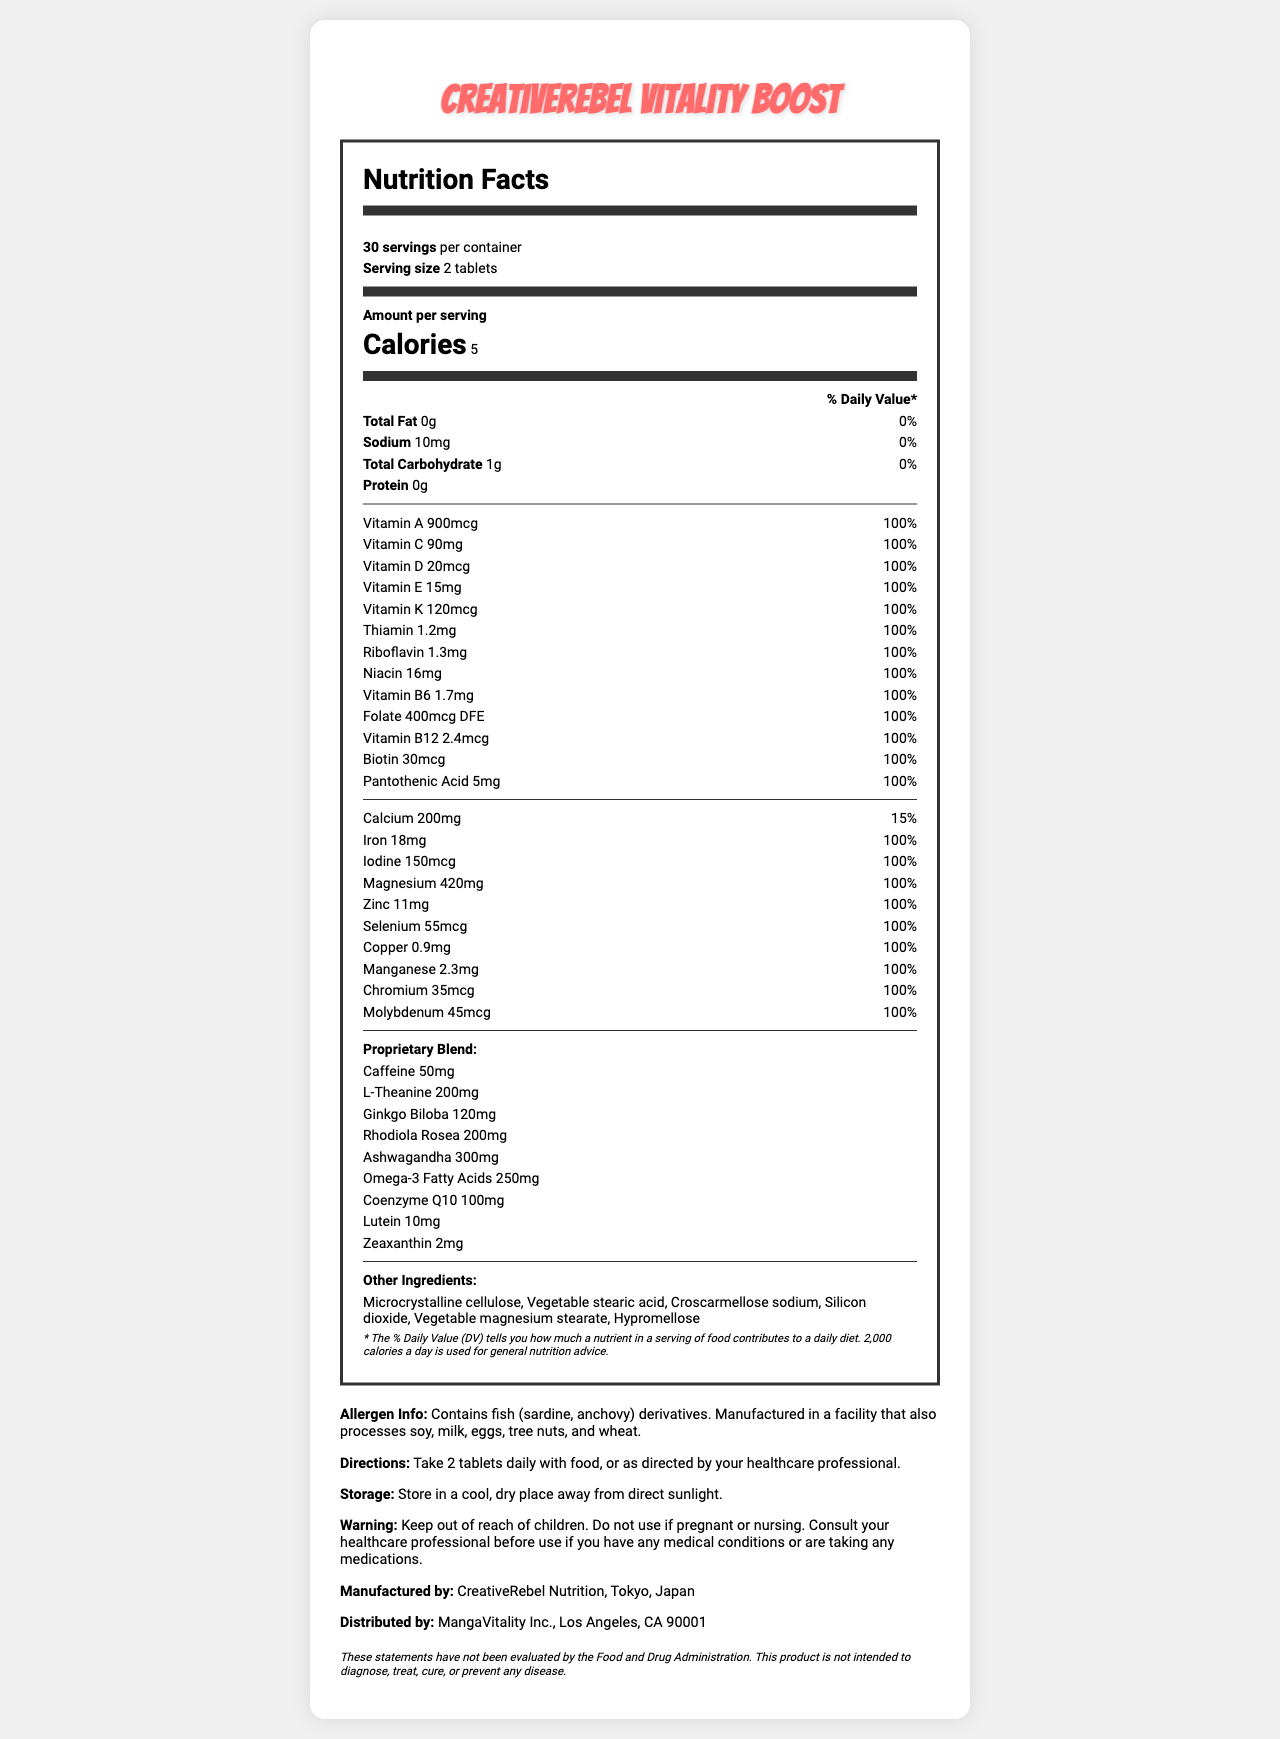what is the serving size? The serving size is clearly stated as "2 tablets" in the document.
Answer: 2 tablets how many servings are in one container? The document mentions that there are 30 servings per container.
Answer: 30 how many calories are in a serving? The document specifies that there are 5 calories per serving.
Answer: 5 how much caffeine is in each serving? The "Proprietary Blend" section lists caffeine content as 50 mg per serving.
Answer: 50 mg which nutrient has the highest daily value percentage? The document shows that Vitamin A, along with several other vitamins and minerals, provides 100% of the daily value.
Answer: Vitamin A what should you do before using if you are pregnant? The warning section explicitly advises consulting a healthcare professional before use if pregnant.
Answer: Consult your healthcare professional how much magnesium is provided per serving? The magnesium content is listed as 420 mg per serving in the document.
Answer: 420 mg which company distributes CreativeRebel Vitality Boost? The distribution information states that MangaVitality Inc. distributes the product.
Answer: MangaVitality Inc., Los Angeles, CA 90001 what ingredients are excluded due to allergens? A. Fish and soy B. Shellfish and milk C. Peanuts and eggs The allergen info specifically mentions it contains fish derivatives and is manufactured in a facility that processes soy.
Answer: A. Fish and soy how much vitamin C is in each serving? A. 60 mg B. 75 mg C. 90 mg D. 120 mg The Vitamin C content is listed as 90 mg per serving.
Answer: C. 90 mg are there any instructions for storage? A. Yes B. No The document provides storage instructions stating "Store in a cool, dry place away from direct sunlight."
Answer: A. Yes is the product intended to cure any diseases? The disclaimer makes it clear that the product is not intended to diagnose, treat, cure, or prevent any disease.
Answer: No does the product include any iron? The nutrition label indicates that the product contains 18 mg of iron per serving.
Answer: Yes what vitamins are provided at 100% daily value per serving? Each of these vitamins and minerals are listed with their respective "100%" daily value percentages.
Answer: Vitamin A, Vitamin C, Vitamin D, Vitamin E, Vitamin K, Thiamin, Riboflavin, Niacin, Vitamin B6, Folate, Vitamin B12, Biotin, Pantothenic Acid, Iron, Iodine, Magnesium, Zinc, Selenium, Copper, Manganese, Chromium, Molybdenum how much of the proprietary blend is ashwagandha? The proprietary blend lists ashwagandha content as 300 mg per serving.
Answer: 300 mg what should you do if you take medications and want to use this supplement? The warning section advises consulting a healthcare professional before use if you are taking any medications.
Answer: Consult your healthcare professional who manufactures CreativeRebel Vitality Boost? The manufacturing information states that CreativeRebel Nutrition manufactures the product.
Answer: CreativeRebel Nutrition, Tokyo, Japan summarize the main idea of the document. The main idea is to present all the essential details about the supplement, including its nutritional content, instructions for use, and safety warnings.
Answer: The document details the nutrition facts, ingredients, allergen information, usage instructions, storage guidelines, and warning for the vitamin supplement "CreativeRebel Vitality Boost". It aims to support the health and vitality of creative professionals by providing a comprehensive blend of essential vitamins, minerals, and other beneficial compounds. can you determine the taste of the tablets? The document does not provide any information regarding the taste of the tablets.
Answer: Cannot be determined 